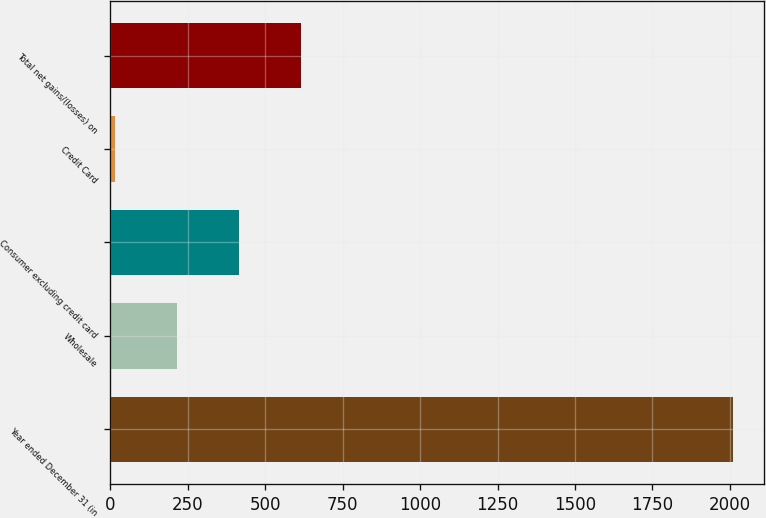Convert chart to OTSL. <chart><loc_0><loc_0><loc_500><loc_500><bar_chart><fcel>Year ended December 31 (in<fcel>Wholesale<fcel>Consumer excluding credit card<fcel>Credit Card<fcel>Total net gains/(losses) on<nl><fcel>2010<fcel>215.4<fcel>414.8<fcel>16<fcel>614.2<nl></chart> 